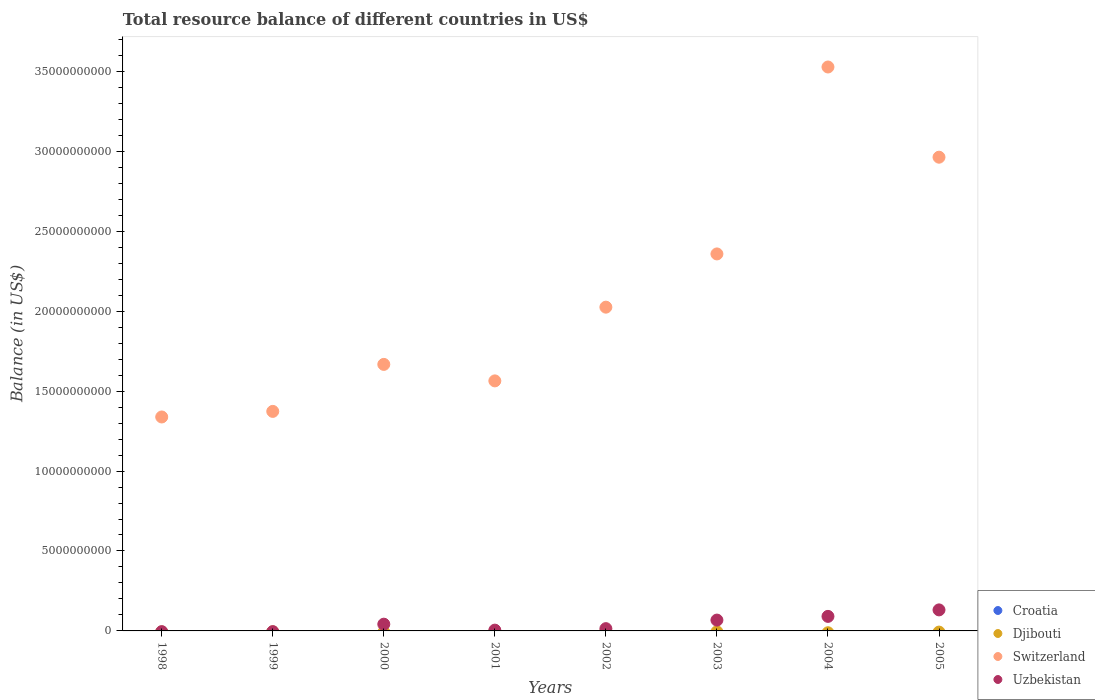How many different coloured dotlines are there?
Provide a short and direct response. 2. What is the total resource balance in Switzerland in 2001?
Provide a short and direct response. 1.56e+1. Across all years, what is the maximum total resource balance in Switzerland?
Give a very brief answer. 3.53e+1. In which year was the total resource balance in Uzbekistan maximum?
Give a very brief answer. 2005. What is the total total resource balance in Switzerland in the graph?
Keep it short and to the point. 1.68e+11. What is the difference between the total resource balance in Switzerland in 2000 and that in 2002?
Your answer should be very brief. -3.58e+09. What is the difference between the total resource balance in Croatia in 1998 and the total resource balance in Switzerland in 2003?
Ensure brevity in your answer.  -2.36e+1. What is the average total resource balance in Croatia per year?
Give a very brief answer. 0. In the year 2002, what is the difference between the total resource balance in Uzbekistan and total resource balance in Switzerland?
Offer a terse response. -2.01e+1. In how many years, is the total resource balance in Uzbekistan greater than 18000000000 US$?
Make the answer very short. 0. What is the ratio of the total resource balance in Uzbekistan in 2002 to that in 2004?
Your answer should be very brief. 0.16. Is the total resource balance in Uzbekistan in 2001 less than that in 2002?
Keep it short and to the point. Yes. What is the difference between the highest and the lowest total resource balance in Switzerland?
Your answer should be compact. 2.19e+1. Is it the case that in every year, the sum of the total resource balance in Uzbekistan and total resource balance in Croatia  is greater than the total resource balance in Djibouti?
Provide a succinct answer. No. Does the total resource balance in Uzbekistan monotonically increase over the years?
Give a very brief answer. No. Is the total resource balance in Djibouti strictly less than the total resource balance in Switzerland over the years?
Give a very brief answer. Yes. How many dotlines are there?
Provide a short and direct response. 2. How many years are there in the graph?
Provide a succinct answer. 8. Are the values on the major ticks of Y-axis written in scientific E-notation?
Give a very brief answer. No. Does the graph contain any zero values?
Give a very brief answer. Yes. What is the title of the graph?
Offer a very short reply. Total resource balance of different countries in US$. What is the label or title of the X-axis?
Your answer should be compact. Years. What is the label or title of the Y-axis?
Ensure brevity in your answer.  Balance (in US$). What is the Balance (in US$) of Djibouti in 1998?
Your answer should be compact. 0. What is the Balance (in US$) of Switzerland in 1998?
Provide a short and direct response. 1.34e+1. What is the Balance (in US$) in Croatia in 1999?
Keep it short and to the point. 0. What is the Balance (in US$) in Djibouti in 1999?
Make the answer very short. 0. What is the Balance (in US$) in Switzerland in 1999?
Provide a short and direct response. 1.37e+1. What is the Balance (in US$) of Uzbekistan in 1999?
Provide a short and direct response. 0. What is the Balance (in US$) of Croatia in 2000?
Your answer should be very brief. 0. What is the Balance (in US$) of Switzerland in 2000?
Your response must be concise. 1.67e+1. What is the Balance (in US$) of Uzbekistan in 2000?
Provide a short and direct response. 4.22e+08. What is the Balance (in US$) of Djibouti in 2001?
Ensure brevity in your answer.  0. What is the Balance (in US$) in Switzerland in 2001?
Keep it short and to the point. 1.56e+1. What is the Balance (in US$) of Uzbekistan in 2001?
Your answer should be very brief. 4.90e+07. What is the Balance (in US$) of Switzerland in 2002?
Provide a short and direct response. 2.02e+1. What is the Balance (in US$) in Uzbekistan in 2002?
Keep it short and to the point. 1.42e+08. What is the Balance (in US$) in Croatia in 2003?
Provide a short and direct response. 0. What is the Balance (in US$) of Djibouti in 2003?
Make the answer very short. 0. What is the Balance (in US$) of Switzerland in 2003?
Provide a short and direct response. 2.36e+1. What is the Balance (in US$) in Uzbekistan in 2003?
Your answer should be very brief. 6.78e+08. What is the Balance (in US$) in Croatia in 2004?
Provide a succinct answer. 0. What is the Balance (in US$) of Djibouti in 2004?
Offer a terse response. 0. What is the Balance (in US$) in Switzerland in 2004?
Keep it short and to the point. 3.53e+1. What is the Balance (in US$) of Uzbekistan in 2004?
Your response must be concise. 9.09e+08. What is the Balance (in US$) of Switzerland in 2005?
Make the answer very short. 2.96e+1. What is the Balance (in US$) in Uzbekistan in 2005?
Your answer should be very brief. 1.32e+09. Across all years, what is the maximum Balance (in US$) in Switzerland?
Offer a terse response. 3.53e+1. Across all years, what is the maximum Balance (in US$) in Uzbekistan?
Make the answer very short. 1.32e+09. Across all years, what is the minimum Balance (in US$) in Switzerland?
Your answer should be very brief. 1.34e+1. What is the total Balance (in US$) in Djibouti in the graph?
Your response must be concise. 0. What is the total Balance (in US$) in Switzerland in the graph?
Provide a short and direct response. 1.68e+11. What is the total Balance (in US$) of Uzbekistan in the graph?
Ensure brevity in your answer.  3.51e+09. What is the difference between the Balance (in US$) in Switzerland in 1998 and that in 1999?
Offer a terse response. -3.49e+08. What is the difference between the Balance (in US$) of Switzerland in 1998 and that in 2000?
Give a very brief answer. -3.29e+09. What is the difference between the Balance (in US$) in Switzerland in 1998 and that in 2001?
Your response must be concise. -2.26e+09. What is the difference between the Balance (in US$) of Switzerland in 1998 and that in 2002?
Ensure brevity in your answer.  -6.87e+09. What is the difference between the Balance (in US$) of Switzerland in 1998 and that in 2003?
Provide a short and direct response. -1.02e+1. What is the difference between the Balance (in US$) in Switzerland in 1998 and that in 2004?
Ensure brevity in your answer.  -2.19e+1. What is the difference between the Balance (in US$) of Switzerland in 1998 and that in 2005?
Make the answer very short. -1.62e+1. What is the difference between the Balance (in US$) in Switzerland in 1999 and that in 2000?
Make the answer very short. -2.94e+09. What is the difference between the Balance (in US$) of Switzerland in 1999 and that in 2001?
Your answer should be compact. -1.91e+09. What is the difference between the Balance (in US$) in Switzerland in 1999 and that in 2002?
Keep it short and to the point. -6.52e+09. What is the difference between the Balance (in US$) in Switzerland in 1999 and that in 2003?
Your answer should be very brief. -9.85e+09. What is the difference between the Balance (in US$) of Switzerland in 1999 and that in 2004?
Give a very brief answer. -2.15e+1. What is the difference between the Balance (in US$) of Switzerland in 1999 and that in 2005?
Offer a terse response. -1.59e+1. What is the difference between the Balance (in US$) of Switzerland in 2000 and that in 2001?
Ensure brevity in your answer.  1.03e+09. What is the difference between the Balance (in US$) of Uzbekistan in 2000 and that in 2001?
Keep it short and to the point. 3.72e+08. What is the difference between the Balance (in US$) in Switzerland in 2000 and that in 2002?
Your answer should be compact. -3.58e+09. What is the difference between the Balance (in US$) in Uzbekistan in 2000 and that in 2002?
Your answer should be compact. 2.80e+08. What is the difference between the Balance (in US$) of Switzerland in 2000 and that in 2003?
Your answer should be compact. -6.91e+09. What is the difference between the Balance (in US$) in Uzbekistan in 2000 and that in 2003?
Provide a succinct answer. -2.56e+08. What is the difference between the Balance (in US$) in Switzerland in 2000 and that in 2004?
Your answer should be very brief. -1.86e+1. What is the difference between the Balance (in US$) of Uzbekistan in 2000 and that in 2004?
Offer a terse response. -4.88e+08. What is the difference between the Balance (in US$) of Switzerland in 2000 and that in 2005?
Make the answer very short. -1.30e+1. What is the difference between the Balance (in US$) in Uzbekistan in 2000 and that in 2005?
Offer a terse response. -8.94e+08. What is the difference between the Balance (in US$) in Switzerland in 2001 and that in 2002?
Offer a terse response. -4.61e+09. What is the difference between the Balance (in US$) in Uzbekistan in 2001 and that in 2002?
Give a very brief answer. -9.30e+07. What is the difference between the Balance (in US$) in Switzerland in 2001 and that in 2003?
Give a very brief answer. -7.94e+09. What is the difference between the Balance (in US$) of Uzbekistan in 2001 and that in 2003?
Provide a short and direct response. -6.29e+08. What is the difference between the Balance (in US$) of Switzerland in 2001 and that in 2004?
Provide a short and direct response. -1.96e+1. What is the difference between the Balance (in US$) of Uzbekistan in 2001 and that in 2004?
Keep it short and to the point. -8.60e+08. What is the difference between the Balance (in US$) in Switzerland in 2001 and that in 2005?
Give a very brief answer. -1.40e+1. What is the difference between the Balance (in US$) in Uzbekistan in 2001 and that in 2005?
Offer a very short reply. -1.27e+09. What is the difference between the Balance (in US$) in Switzerland in 2002 and that in 2003?
Give a very brief answer. -3.33e+09. What is the difference between the Balance (in US$) in Uzbekistan in 2002 and that in 2003?
Your answer should be compact. -5.36e+08. What is the difference between the Balance (in US$) of Switzerland in 2002 and that in 2004?
Provide a succinct answer. -1.50e+1. What is the difference between the Balance (in US$) of Uzbekistan in 2002 and that in 2004?
Your response must be concise. -7.67e+08. What is the difference between the Balance (in US$) of Switzerland in 2002 and that in 2005?
Ensure brevity in your answer.  -9.38e+09. What is the difference between the Balance (in US$) of Uzbekistan in 2002 and that in 2005?
Make the answer very short. -1.17e+09. What is the difference between the Balance (in US$) in Switzerland in 2003 and that in 2004?
Offer a very short reply. -1.17e+1. What is the difference between the Balance (in US$) of Uzbekistan in 2003 and that in 2004?
Ensure brevity in your answer.  -2.31e+08. What is the difference between the Balance (in US$) in Switzerland in 2003 and that in 2005?
Your response must be concise. -6.05e+09. What is the difference between the Balance (in US$) in Uzbekistan in 2003 and that in 2005?
Make the answer very short. -6.37e+08. What is the difference between the Balance (in US$) in Switzerland in 2004 and that in 2005?
Your response must be concise. 5.64e+09. What is the difference between the Balance (in US$) in Uzbekistan in 2004 and that in 2005?
Offer a very short reply. -4.06e+08. What is the difference between the Balance (in US$) in Switzerland in 1998 and the Balance (in US$) in Uzbekistan in 2000?
Offer a terse response. 1.30e+1. What is the difference between the Balance (in US$) of Switzerland in 1998 and the Balance (in US$) of Uzbekistan in 2001?
Ensure brevity in your answer.  1.33e+1. What is the difference between the Balance (in US$) of Switzerland in 1998 and the Balance (in US$) of Uzbekistan in 2002?
Provide a short and direct response. 1.32e+1. What is the difference between the Balance (in US$) of Switzerland in 1998 and the Balance (in US$) of Uzbekistan in 2003?
Provide a short and direct response. 1.27e+1. What is the difference between the Balance (in US$) of Switzerland in 1998 and the Balance (in US$) of Uzbekistan in 2004?
Ensure brevity in your answer.  1.25e+1. What is the difference between the Balance (in US$) of Switzerland in 1998 and the Balance (in US$) of Uzbekistan in 2005?
Ensure brevity in your answer.  1.21e+1. What is the difference between the Balance (in US$) in Switzerland in 1999 and the Balance (in US$) in Uzbekistan in 2000?
Make the answer very short. 1.33e+1. What is the difference between the Balance (in US$) in Switzerland in 1999 and the Balance (in US$) in Uzbekistan in 2001?
Your answer should be compact. 1.37e+1. What is the difference between the Balance (in US$) in Switzerland in 1999 and the Balance (in US$) in Uzbekistan in 2002?
Offer a very short reply. 1.36e+1. What is the difference between the Balance (in US$) in Switzerland in 1999 and the Balance (in US$) in Uzbekistan in 2003?
Provide a succinct answer. 1.31e+1. What is the difference between the Balance (in US$) in Switzerland in 1999 and the Balance (in US$) in Uzbekistan in 2004?
Offer a very short reply. 1.28e+1. What is the difference between the Balance (in US$) in Switzerland in 1999 and the Balance (in US$) in Uzbekistan in 2005?
Your answer should be very brief. 1.24e+1. What is the difference between the Balance (in US$) of Switzerland in 2000 and the Balance (in US$) of Uzbekistan in 2001?
Give a very brief answer. 1.66e+1. What is the difference between the Balance (in US$) in Switzerland in 2000 and the Balance (in US$) in Uzbekistan in 2002?
Make the answer very short. 1.65e+1. What is the difference between the Balance (in US$) of Switzerland in 2000 and the Balance (in US$) of Uzbekistan in 2003?
Your answer should be compact. 1.60e+1. What is the difference between the Balance (in US$) in Switzerland in 2000 and the Balance (in US$) in Uzbekistan in 2004?
Your response must be concise. 1.58e+1. What is the difference between the Balance (in US$) of Switzerland in 2000 and the Balance (in US$) of Uzbekistan in 2005?
Offer a terse response. 1.54e+1. What is the difference between the Balance (in US$) of Switzerland in 2001 and the Balance (in US$) of Uzbekistan in 2002?
Keep it short and to the point. 1.55e+1. What is the difference between the Balance (in US$) of Switzerland in 2001 and the Balance (in US$) of Uzbekistan in 2003?
Provide a succinct answer. 1.50e+1. What is the difference between the Balance (in US$) in Switzerland in 2001 and the Balance (in US$) in Uzbekistan in 2004?
Your answer should be very brief. 1.47e+1. What is the difference between the Balance (in US$) of Switzerland in 2001 and the Balance (in US$) of Uzbekistan in 2005?
Ensure brevity in your answer.  1.43e+1. What is the difference between the Balance (in US$) of Switzerland in 2002 and the Balance (in US$) of Uzbekistan in 2003?
Your response must be concise. 1.96e+1. What is the difference between the Balance (in US$) of Switzerland in 2002 and the Balance (in US$) of Uzbekistan in 2004?
Your response must be concise. 1.93e+1. What is the difference between the Balance (in US$) in Switzerland in 2002 and the Balance (in US$) in Uzbekistan in 2005?
Ensure brevity in your answer.  1.89e+1. What is the difference between the Balance (in US$) of Switzerland in 2003 and the Balance (in US$) of Uzbekistan in 2004?
Ensure brevity in your answer.  2.27e+1. What is the difference between the Balance (in US$) in Switzerland in 2003 and the Balance (in US$) in Uzbekistan in 2005?
Offer a terse response. 2.23e+1. What is the difference between the Balance (in US$) in Switzerland in 2004 and the Balance (in US$) in Uzbekistan in 2005?
Your answer should be compact. 3.40e+1. What is the average Balance (in US$) in Djibouti per year?
Your answer should be very brief. 0. What is the average Balance (in US$) of Switzerland per year?
Your answer should be compact. 2.10e+1. What is the average Balance (in US$) of Uzbekistan per year?
Your response must be concise. 4.39e+08. In the year 2000, what is the difference between the Balance (in US$) in Switzerland and Balance (in US$) in Uzbekistan?
Provide a succinct answer. 1.62e+1. In the year 2001, what is the difference between the Balance (in US$) of Switzerland and Balance (in US$) of Uzbekistan?
Offer a very short reply. 1.56e+1. In the year 2002, what is the difference between the Balance (in US$) in Switzerland and Balance (in US$) in Uzbekistan?
Offer a terse response. 2.01e+1. In the year 2003, what is the difference between the Balance (in US$) in Switzerland and Balance (in US$) in Uzbekistan?
Your answer should be very brief. 2.29e+1. In the year 2004, what is the difference between the Balance (in US$) of Switzerland and Balance (in US$) of Uzbekistan?
Offer a terse response. 3.44e+1. In the year 2005, what is the difference between the Balance (in US$) of Switzerland and Balance (in US$) of Uzbekistan?
Offer a very short reply. 2.83e+1. What is the ratio of the Balance (in US$) of Switzerland in 1998 to that in 1999?
Make the answer very short. 0.97. What is the ratio of the Balance (in US$) of Switzerland in 1998 to that in 2000?
Provide a short and direct response. 0.8. What is the ratio of the Balance (in US$) of Switzerland in 1998 to that in 2001?
Offer a very short reply. 0.86. What is the ratio of the Balance (in US$) in Switzerland in 1998 to that in 2002?
Ensure brevity in your answer.  0.66. What is the ratio of the Balance (in US$) in Switzerland in 1998 to that in 2003?
Your response must be concise. 0.57. What is the ratio of the Balance (in US$) of Switzerland in 1998 to that in 2004?
Offer a terse response. 0.38. What is the ratio of the Balance (in US$) of Switzerland in 1998 to that in 2005?
Offer a very short reply. 0.45. What is the ratio of the Balance (in US$) in Switzerland in 1999 to that in 2000?
Provide a short and direct response. 0.82. What is the ratio of the Balance (in US$) of Switzerland in 1999 to that in 2001?
Your answer should be very brief. 0.88. What is the ratio of the Balance (in US$) of Switzerland in 1999 to that in 2002?
Provide a short and direct response. 0.68. What is the ratio of the Balance (in US$) in Switzerland in 1999 to that in 2003?
Ensure brevity in your answer.  0.58. What is the ratio of the Balance (in US$) in Switzerland in 1999 to that in 2004?
Offer a very short reply. 0.39. What is the ratio of the Balance (in US$) in Switzerland in 1999 to that in 2005?
Your answer should be compact. 0.46. What is the ratio of the Balance (in US$) in Switzerland in 2000 to that in 2001?
Make the answer very short. 1.07. What is the ratio of the Balance (in US$) of Uzbekistan in 2000 to that in 2001?
Your response must be concise. 8.6. What is the ratio of the Balance (in US$) in Switzerland in 2000 to that in 2002?
Offer a very short reply. 0.82. What is the ratio of the Balance (in US$) in Uzbekistan in 2000 to that in 2002?
Offer a terse response. 2.97. What is the ratio of the Balance (in US$) in Switzerland in 2000 to that in 2003?
Provide a short and direct response. 0.71. What is the ratio of the Balance (in US$) of Uzbekistan in 2000 to that in 2003?
Offer a very short reply. 0.62. What is the ratio of the Balance (in US$) of Switzerland in 2000 to that in 2004?
Ensure brevity in your answer.  0.47. What is the ratio of the Balance (in US$) in Uzbekistan in 2000 to that in 2004?
Offer a very short reply. 0.46. What is the ratio of the Balance (in US$) in Switzerland in 2000 to that in 2005?
Your answer should be compact. 0.56. What is the ratio of the Balance (in US$) in Uzbekistan in 2000 to that in 2005?
Your response must be concise. 0.32. What is the ratio of the Balance (in US$) of Switzerland in 2001 to that in 2002?
Offer a terse response. 0.77. What is the ratio of the Balance (in US$) of Uzbekistan in 2001 to that in 2002?
Provide a succinct answer. 0.35. What is the ratio of the Balance (in US$) of Switzerland in 2001 to that in 2003?
Provide a succinct answer. 0.66. What is the ratio of the Balance (in US$) of Uzbekistan in 2001 to that in 2003?
Make the answer very short. 0.07. What is the ratio of the Balance (in US$) of Switzerland in 2001 to that in 2004?
Your answer should be very brief. 0.44. What is the ratio of the Balance (in US$) in Uzbekistan in 2001 to that in 2004?
Your answer should be very brief. 0.05. What is the ratio of the Balance (in US$) in Switzerland in 2001 to that in 2005?
Provide a short and direct response. 0.53. What is the ratio of the Balance (in US$) of Uzbekistan in 2001 to that in 2005?
Provide a short and direct response. 0.04. What is the ratio of the Balance (in US$) of Switzerland in 2002 to that in 2003?
Keep it short and to the point. 0.86. What is the ratio of the Balance (in US$) in Uzbekistan in 2002 to that in 2003?
Give a very brief answer. 0.21. What is the ratio of the Balance (in US$) of Switzerland in 2002 to that in 2004?
Your answer should be compact. 0.57. What is the ratio of the Balance (in US$) in Uzbekistan in 2002 to that in 2004?
Provide a short and direct response. 0.16. What is the ratio of the Balance (in US$) of Switzerland in 2002 to that in 2005?
Keep it short and to the point. 0.68. What is the ratio of the Balance (in US$) of Uzbekistan in 2002 to that in 2005?
Provide a short and direct response. 0.11. What is the ratio of the Balance (in US$) of Switzerland in 2003 to that in 2004?
Provide a succinct answer. 0.67. What is the ratio of the Balance (in US$) of Uzbekistan in 2003 to that in 2004?
Your answer should be compact. 0.75. What is the ratio of the Balance (in US$) in Switzerland in 2003 to that in 2005?
Make the answer very short. 0.8. What is the ratio of the Balance (in US$) in Uzbekistan in 2003 to that in 2005?
Your answer should be compact. 0.52. What is the ratio of the Balance (in US$) in Switzerland in 2004 to that in 2005?
Your answer should be compact. 1.19. What is the ratio of the Balance (in US$) of Uzbekistan in 2004 to that in 2005?
Give a very brief answer. 0.69. What is the difference between the highest and the second highest Balance (in US$) of Switzerland?
Offer a very short reply. 5.64e+09. What is the difference between the highest and the second highest Balance (in US$) in Uzbekistan?
Give a very brief answer. 4.06e+08. What is the difference between the highest and the lowest Balance (in US$) in Switzerland?
Offer a terse response. 2.19e+1. What is the difference between the highest and the lowest Balance (in US$) of Uzbekistan?
Keep it short and to the point. 1.32e+09. 